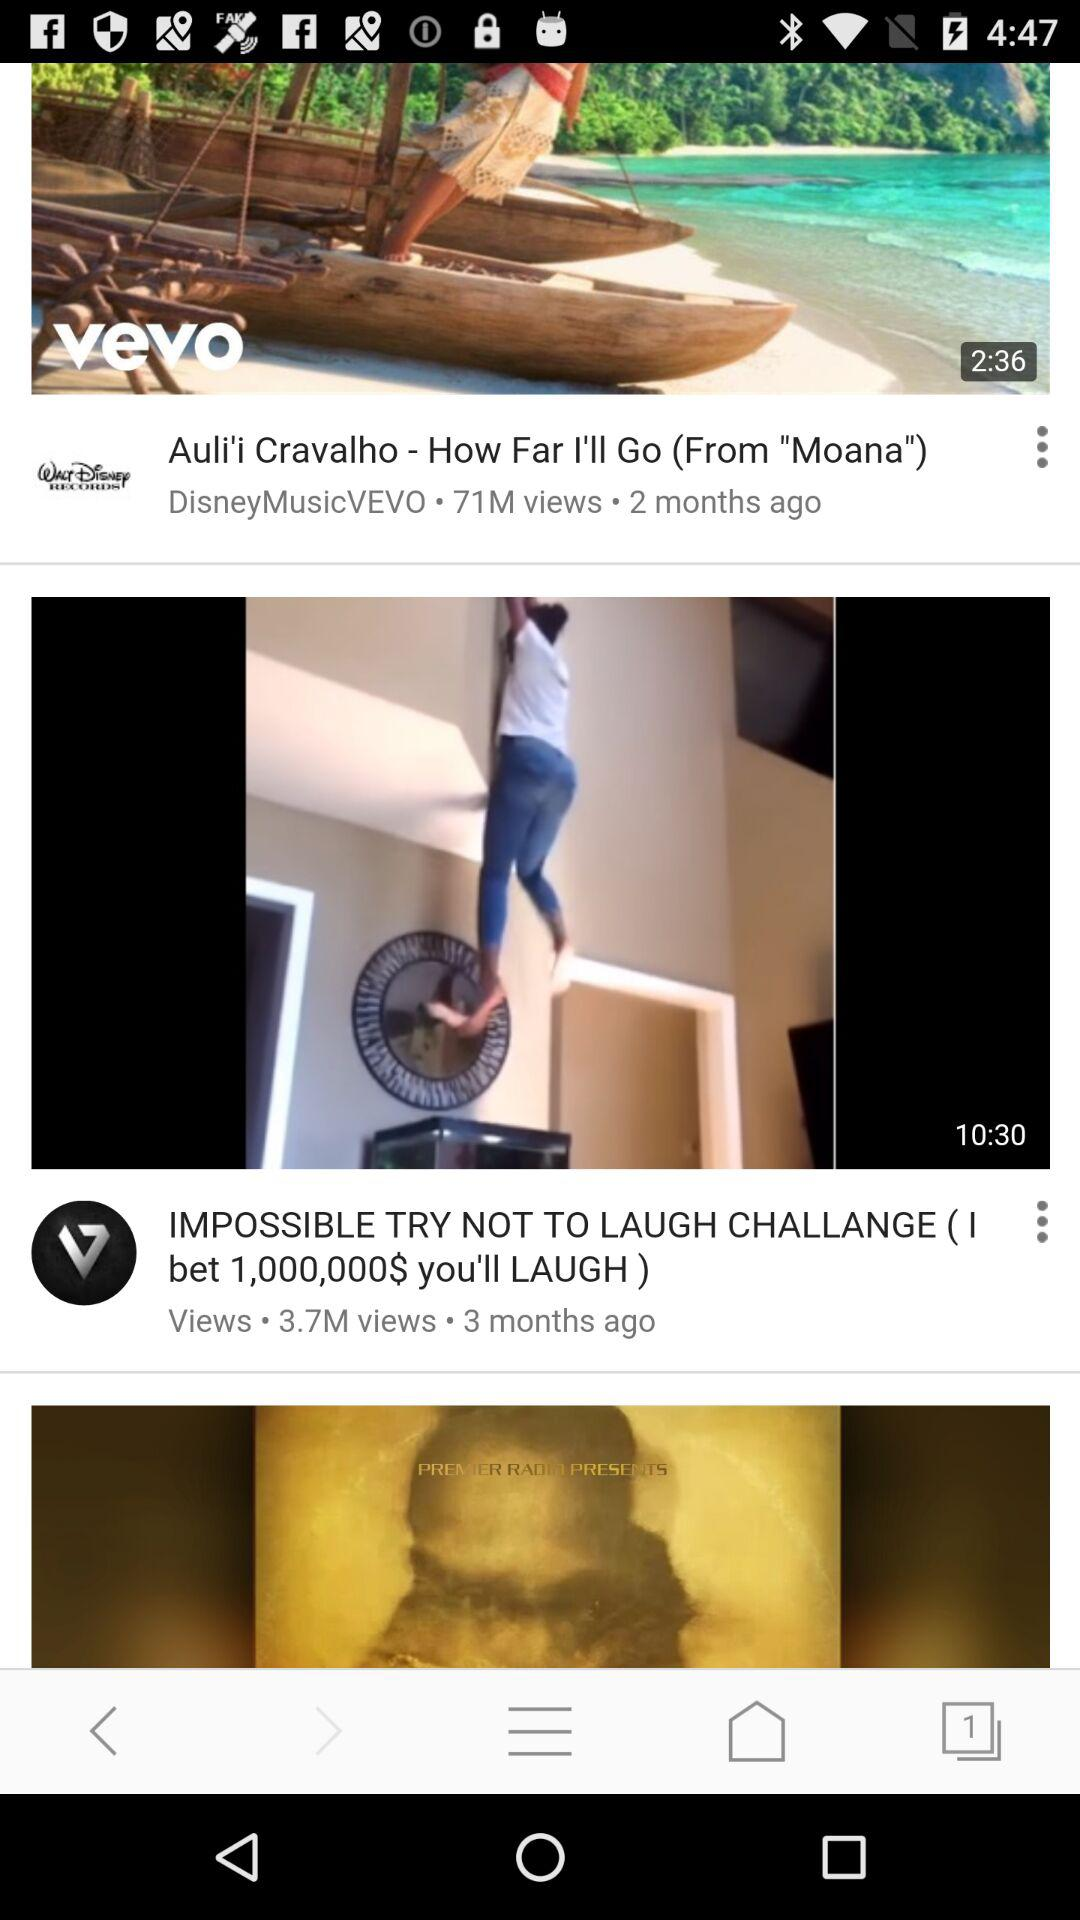On what days were the videos posted?
When the provided information is insufficient, respond with <no answer>. <no answer> 